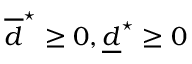Convert formula to latex. <formula><loc_0><loc_0><loc_500><loc_500>\overline { d } ^ { ^ { * } } \geq 0 , \underline { d } ^ { ^ { * } } \geq 0</formula> 